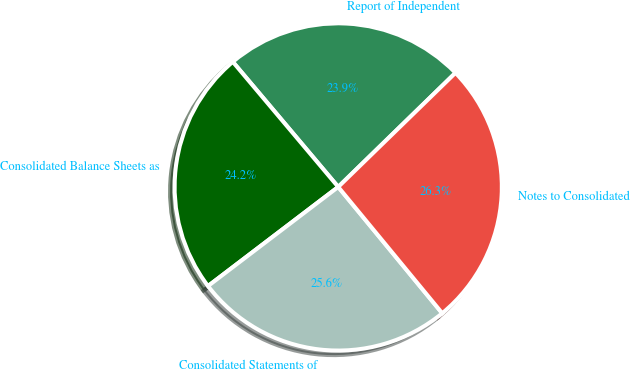Convert chart. <chart><loc_0><loc_0><loc_500><loc_500><pie_chart><fcel>Report of Independent<fcel>Consolidated Balance Sheets as<fcel>Consolidated Statements of<fcel>Notes to Consolidated<nl><fcel>23.86%<fcel>24.21%<fcel>25.61%<fcel>26.32%<nl></chart> 